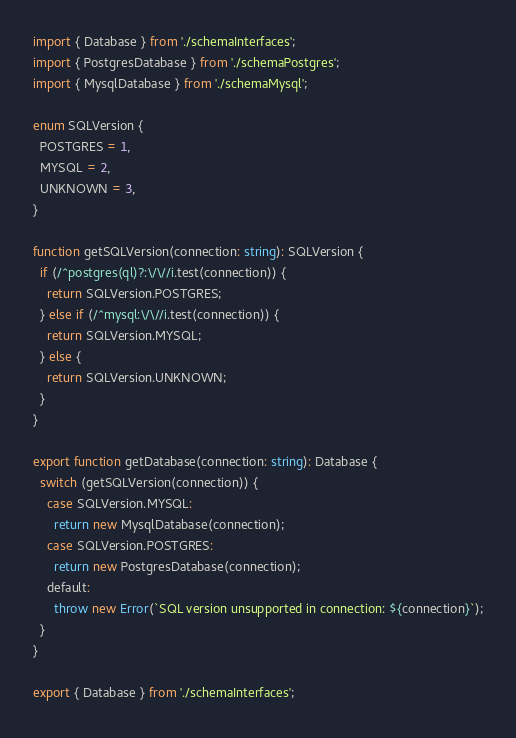<code> <loc_0><loc_0><loc_500><loc_500><_TypeScript_>import { Database } from './schemaInterfaces';
import { PostgresDatabase } from './schemaPostgres';
import { MysqlDatabase } from './schemaMysql';

enum SQLVersion {
  POSTGRES = 1,
  MYSQL = 2,
  UNKNOWN = 3,
}

function getSQLVersion(connection: string): SQLVersion {
  if (/^postgres(ql)?:\/\//i.test(connection)) {
    return SQLVersion.POSTGRES;
  } else if (/^mysql:\/\//i.test(connection)) {
    return SQLVersion.MYSQL;
  } else {
    return SQLVersion.UNKNOWN;
  }
}

export function getDatabase(connection: string): Database {
  switch (getSQLVersion(connection)) {
    case SQLVersion.MYSQL:
      return new MysqlDatabase(connection);
    case SQLVersion.POSTGRES:
      return new PostgresDatabase(connection);
    default:
      throw new Error(`SQL version unsupported in connection: ${connection}`);
  }
}

export { Database } from './schemaInterfaces';
</code> 